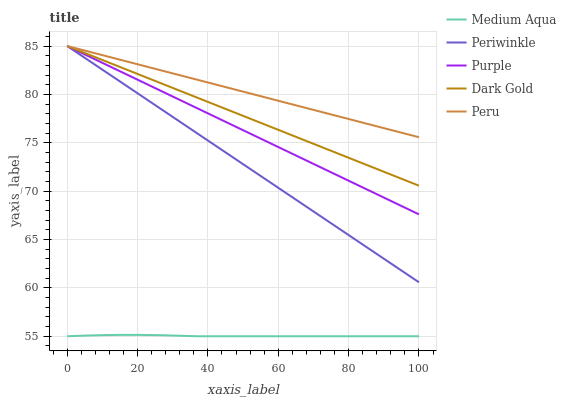Does Medium Aqua have the minimum area under the curve?
Answer yes or no. Yes. Does Peru have the maximum area under the curve?
Answer yes or no. Yes. Does Periwinkle have the minimum area under the curve?
Answer yes or no. No. Does Periwinkle have the maximum area under the curve?
Answer yes or no. No. Is Peru the smoothest?
Answer yes or no. Yes. Is Medium Aqua the roughest?
Answer yes or no. Yes. Is Periwinkle the smoothest?
Answer yes or no. No. Is Periwinkle the roughest?
Answer yes or no. No. Does Medium Aqua have the lowest value?
Answer yes or no. Yes. Does Periwinkle have the lowest value?
Answer yes or no. No. Does Dark Gold have the highest value?
Answer yes or no. Yes. Does Medium Aqua have the highest value?
Answer yes or no. No. Is Medium Aqua less than Dark Gold?
Answer yes or no. Yes. Is Purple greater than Medium Aqua?
Answer yes or no. Yes. Does Dark Gold intersect Peru?
Answer yes or no. Yes. Is Dark Gold less than Peru?
Answer yes or no. No. Is Dark Gold greater than Peru?
Answer yes or no. No. Does Medium Aqua intersect Dark Gold?
Answer yes or no. No. 